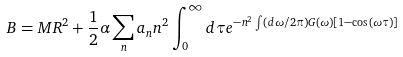<formula> <loc_0><loc_0><loc_500><loc_500>B = M R ^ { 2 } + \frac { 1 } { 2 } \alpha \sum _ { n } a _ { n } n ^ { 2 } \int _ { 0 } ^ { \infty } d \tau e ^ { - n ^ { 2 } \int ( d \omega / 2 \pi ) G ( \omega ) [ 1 - \cos ( \omega \tau ) ] }</formula> 